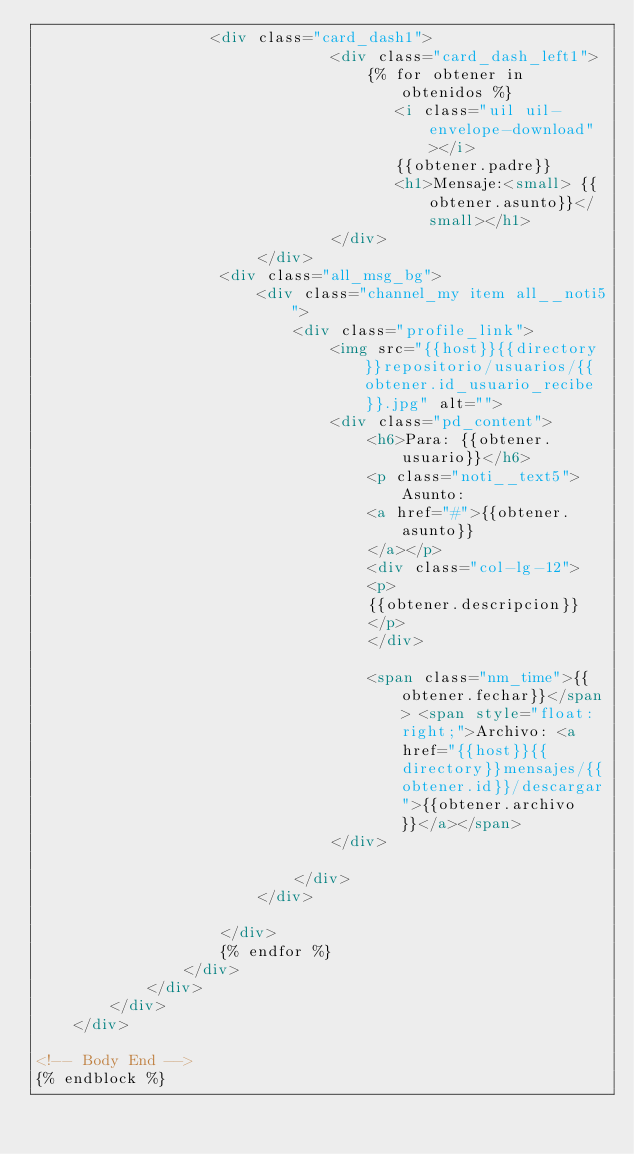Convert code to text. <code><loc_0><loc_0><loc_500><loc_500><_HTML_>                   <div class="card_dash1">
								<div class="card_dash_left1">
                                    {% for obtener in obtenidos %}
                                       <i class="uil uil-envelope-download"></i>
                                       {{obtener.padre}}
									   <h1>Mensaje:<small> {{obtener.asunto}}</small></h1>
								</div>	
					    </div>
                    <div class="all_msg_bg">
                        <div class="channel_my item all__noti5">
                            <div class="profile_link">
                                <img src="{{host}}{{directory}}repositorio/usuarios/{{obtener.id_usuario_recibe}}.jpg" alt="">
                                <div class="pd_content">
                                    <h6>Para: {{obtener.usuario}}</h6>
                                    <p class="noti__text5">Asunto:
                                    <a href="#">{{obtener.asunto}}
                                    </a></p>
                                    <div class="col-lg-12">
                                    <p>
                                    {{obtener.descripcion}}
                                    </p>
                                    </div>
                                    
                                    <span class="nm_time">{{obtener.fechar}}</span> <span style="float:right;">Archivo: <a href="{{host}}{{directory}}mensajes/{{obtener.id}}/descargar">{{obtener.archivo}}</a></span>
                                </div>
                                							
                            </div>							
                        </div>
                       
                    </div>
                    {% endfor %}
                </div>
            </div>
        </div>
    </div>
    
<!-- Body End -->
{% endblock %}
</code> 